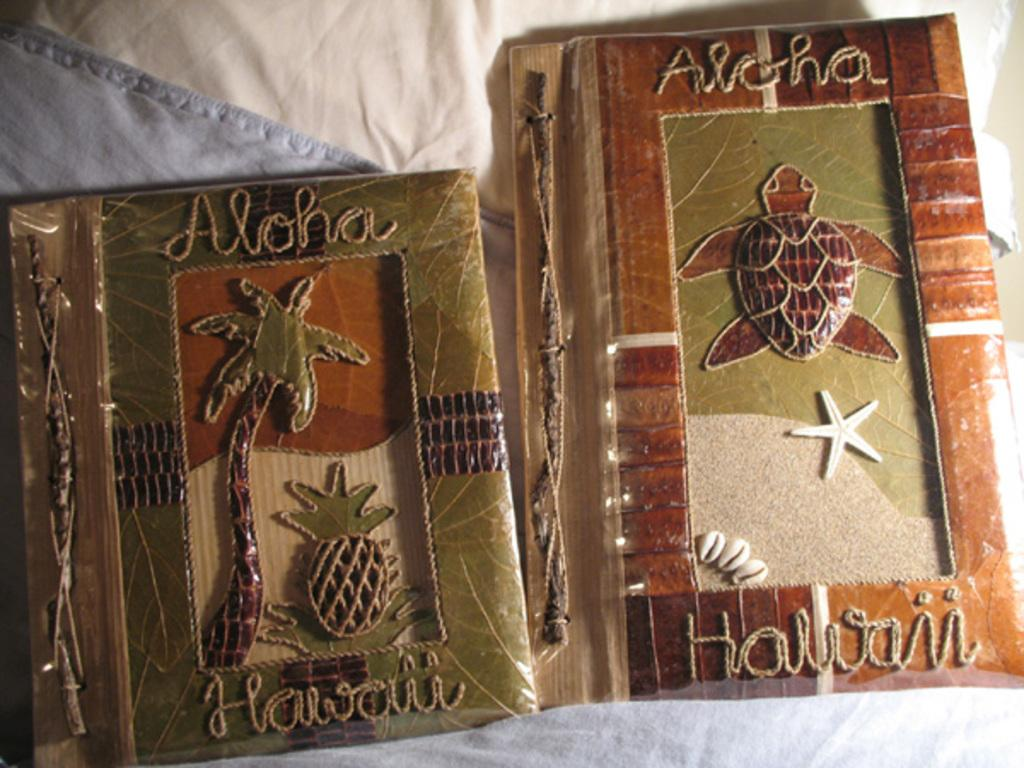Provide a one-sentence caption for the provided image. Two Aloha Hawaii books with a coconut tree and a turtle on their covers are on a bed. 